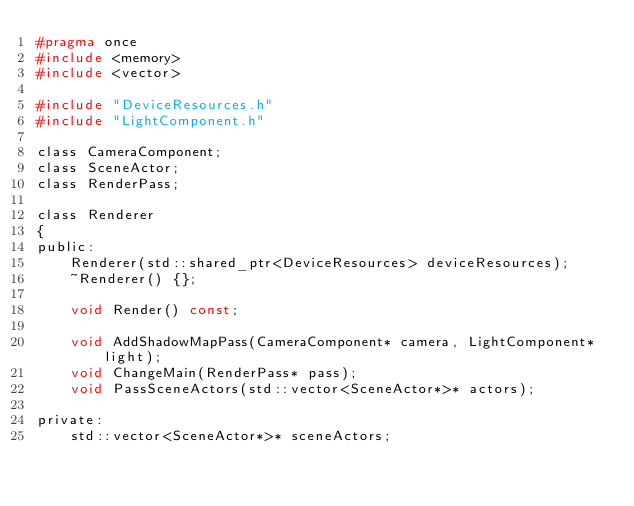<code> <loc_0><loc_0><loc_500><loc_500><_C_>#pragma once
#include <memory>
#include <vector>

#include "DeviceResources.h"
#include "LightComponent.h"

class CameraComponent;
class SceneActor;
class RenderPass;

class Renderer
{
public:
    Renderer(std::shared_ptr<DeviceResources> deviceResources);
    ~Renderer() {};

    void Render() const;

    void AddShadowMapPass(CameraComponent* camera, LightComponent* light);
    void ChangeMain(RenderPass* pass);
    void PassSceneActors(std::vector<SceneActor*>* actors);

private:
    std::vector<SceneActor*>* sceneActors;</code> 